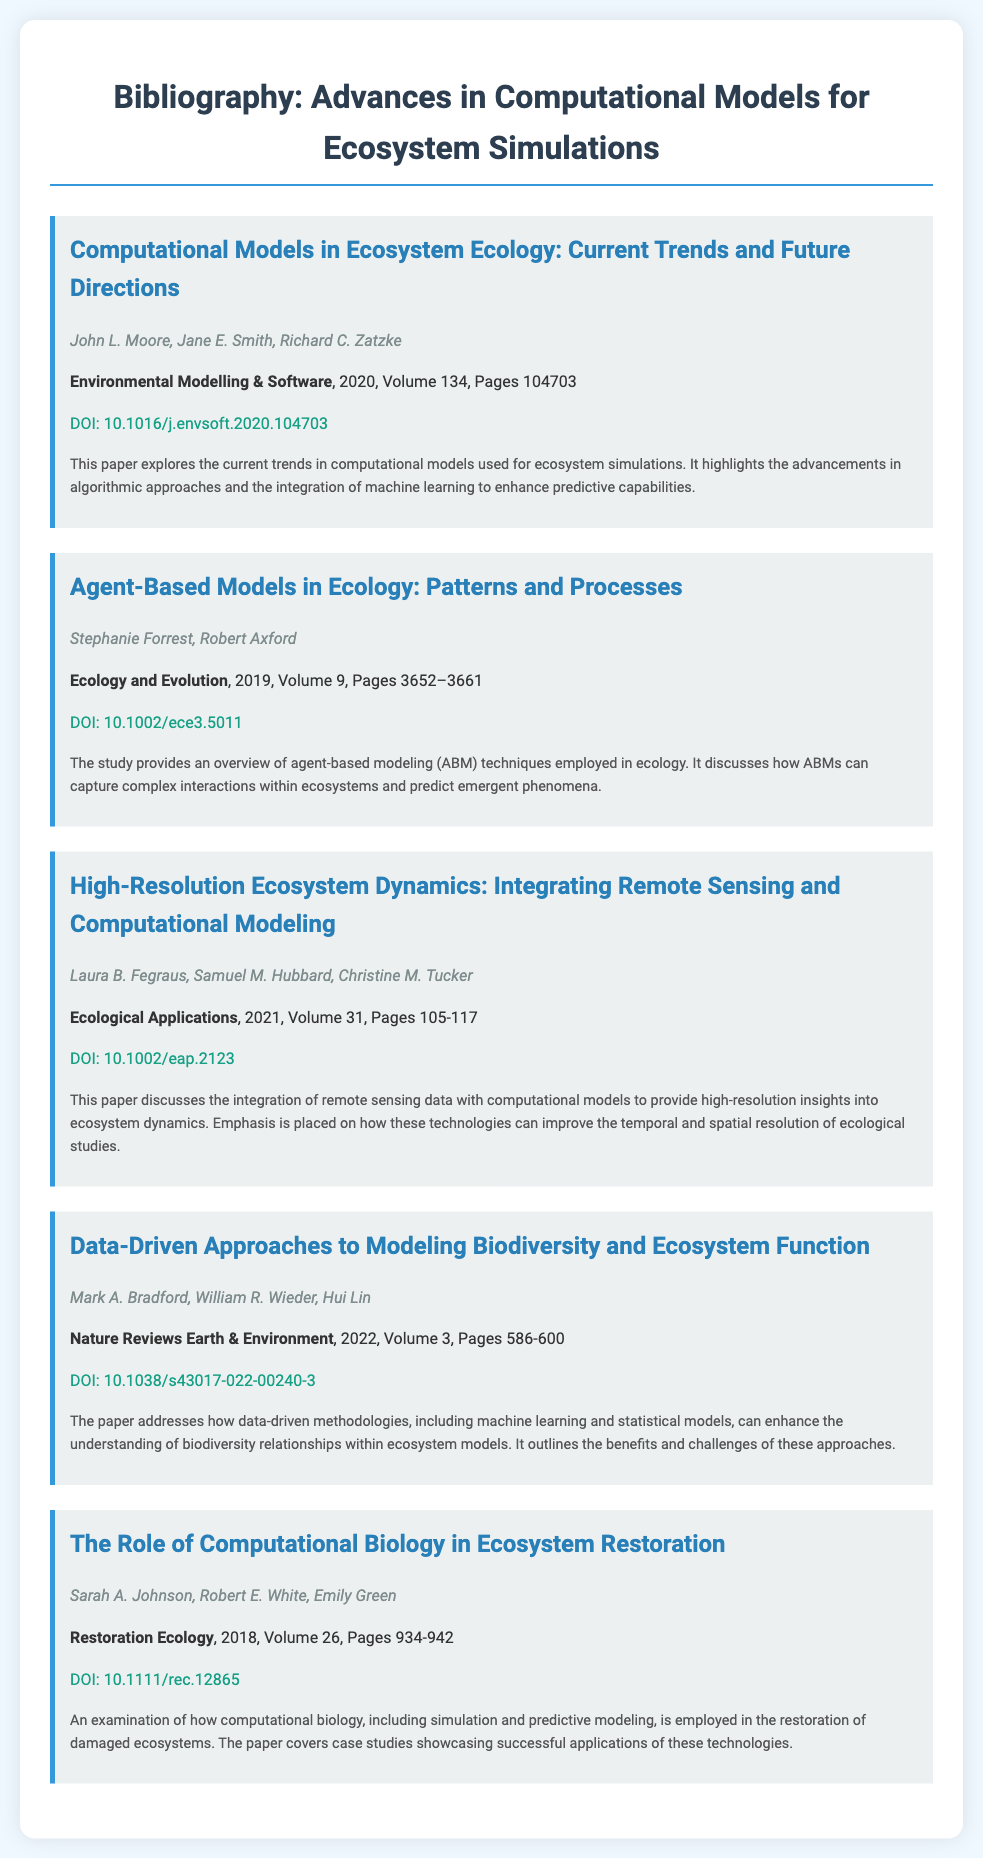What is the title of the first entry? The title of the first entry is specified in the document under the "h2" tag for the first entry.
Answer: Computational Models in Ecosystem Ecology: Current Trends and Future Directions Who are the authors of the paper published in 2021? The authors of the 2021 paper are mentioned in the corresponding entry that lists the publication year.
Answer: Laura B. Fegraus, Samuel M. Hubbard, Christine M. Tucker What volume of "Nature Reviews Earth & Environment" was published in 2022? The volume number is indicated in the citation of the specific entry for that journal and year.
Answer: Volume 3 How many pages does the article "Agent-Based Models in Ecology: Patterns and Processes" cover? The range of pages for that article is provided in the entry for the corresponding paper.
Answer: 3652–3661 What is the DOI for the paper discussing data-driven approaches to modeling biodiversity? The DOI is stated in the entry for the specific paper in the document.
Answer: 10.1038/s43017-022-00240-3 What is a key theme highlighted in the article by John L. Moore et al.? The summary of this article outlines the main themes and advancements being discussed.
Answer: Advancements in algorithmic approaches and machine learning How are agent-based models described in the document? The document summarizes the findings and discussions related to agent-based models in the respective paper.
Answer: Capture complex interactions within ecosystems and predict emergent phenomena In which journal was the article about computational biology in ecosystem restoration published? The journal name is provided in the citation details part of the respective entry.
Answer: Restoration Ecology 